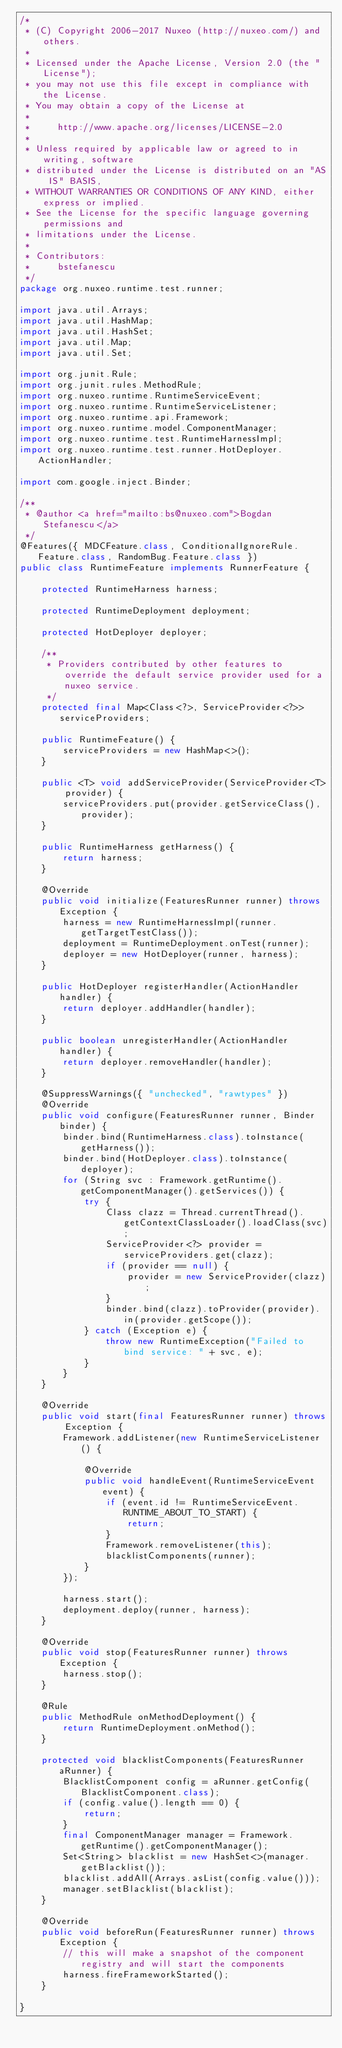Convert code to text. <code><loc_0><loc_0><loc_500><loc_500><_Java_>/*
 * (C) Copyright 2006-2017 Nuxeo (http://nuxeo.com/) and others.
 *
 * Licensed under the Apache License, Version 2.0 (the "License");
 * you may not use this file except in compliance with the License.
 * You may obtain a copy of the License at
 *
 *     http://www.apache.org/licenses/LICENSE-2.0
 *
 * Unless required by applicable law or agreed to in writing, software
 * distributed under the License is distributed on an "AS IS" BASIS,
 * WITHOUT WARRANTIES OR CONDITIONS OF ANY KIND, either express or implied.
 * See the License for the specific language governing permissions and
 * limitations under the License.
 *
 * Contributors:
 *     bstefanescu
 */
package org.nuxeo.runtime.test.runner;

import java.util.Arrays;
import java.util.HashMap;
import java.util.HashSet;
import java.util.Map;
import java.util.Set;

import org.junit.Rule;
import org.junit.rules.MethodRule;
import org.nuxeo.runtime.RuntimeServiceEvent;
import org.nuxeo.runtime.RuntimeServiceListener;
import org.nuxeo.runtime.api.Framework;
import org.nuxeo.runtime.model.ComponentManager;
import org.nuxeo.runtime.test.RuntimeHarnessImpl;
import org.nuxeo.runtime.test.runner.HotDeployer.ActionHandler;

import com.google.inject.Binder;

/**
 * @author <a href="mailto:bs@nuxeo.com">Bogdan Stefanescu</a>
 */
@Features({ MDCFeature.class, ConditionalIgnoreRule.Feature.class, RandomBug.Feature.class })
public class RuntimeFeature implements RunnerFeature {

    protected RuntimeHarness harness;

    protected RuntimeDeployment deployment;

    protected HotDeployer deployer;

    /**
     * Providers contributed by other features to override the default service provider used for a nuxeo service.
     */
    protected final Map<Class<?>, ServiceProvider<?>> serviceProviders;

    public RuntimeFeature() {
        serviceProviders = new HashMap<>();
    }

    public <T> void addServiceProvider(ServiceProvider<T> provider) {
        serviceProviders.put(provider.getServiceClass(), provider);
    }

    public RuntimeHarness getHarness() {
        return harness;
    }

    @Override
    public void initialize(FeaturesRunner runner) throws Exception {
        harness = new RuntimeHarnessImpl(runner.getTargetTestClass());
        deployment = RuntimeDeployment.onTest(runner);
        deployer = new HotDeployer(runner, harness);
    }

    public HotDeployer registerHandler(ActionHandler handler) {
        return deployer.addHandler(handler);
    }

    public boolean unregisterHandler(ActionHandler handler) {
        return deployer.removeHandler(handler);
    }

    @SuppressWarnings({ "unchecked", "rawtypes" })
    @Override
    public void configure(FeaturesRunner runner, Binder binder) {
        binder.bind(RuntimeHarness.class).toInstance(getHarness());
        binder.bind(HotDeployer.class).toInstance(deployer);
        for (String svc : Framework.getRuntime().getComponentManager().getServices()) {
            try {
                Class clazz = Thread.currentThread().getContextClassLoader().loadClass(svc);
                ServiceProvider<?> provider = serviceProviders.get(clazz);
                if (provider == null) {
                    provider = new ServiceProvider(clazz);
                }
                binder.bind(clazz).toProvider(provider).in(provider.getScope());
            } catch (Exception e) {
                throw new RuntimeException("Failed to bind service: " + svc, e);
            }
        }
    }

    @Override
    public void start(final FeaturesRunner runner) throws Exception {
        Framework.addListener(new RuntimeServiceListener() {

            @Override
            public void handleEvent(RuntimeServiceEvent event) {
                if (event.id != RuntimeServiceEvent.RUNTIME_ABOUT_TO_START) {
                    return;
                }
                Framework.removeListener(this);
                blacklistComponents(runner);
            }
        });

        harness.start();
        deployment.deploy(runner, harness);
    }

    @Override
    public void stop(FeaturesRunner runner) throws Exception {
        harness.stop();
    }

    @Rule
    public MethodRule onMethodDeployment() {
        return RuntimeDeployment.onMethod();
    }

    protected void blacklistComponents(FeaturesRunner aRunner) {
        BlacklistComponent config = aRunner.getConfig(BlacklistComponent.class);
        if (config.value().length == 0) {
            return;
        }
        final ComponentManager manager = Framework.getRuntime().getComponentManager();
        Set<String> blacklist = new HashSet<>(manager.getBlacklist());
        blacklist.addAll(Arrays.asList(config.value()));
        manager.setBlacklist(blacklist);
    }

    @Override
    public void beforeRun(FeaturesRunner runner) throws Exception {
        // this will make a snapshot of the component registry and will start the components
        harness.fireFrameworkStarted();
    }

}
</code> 